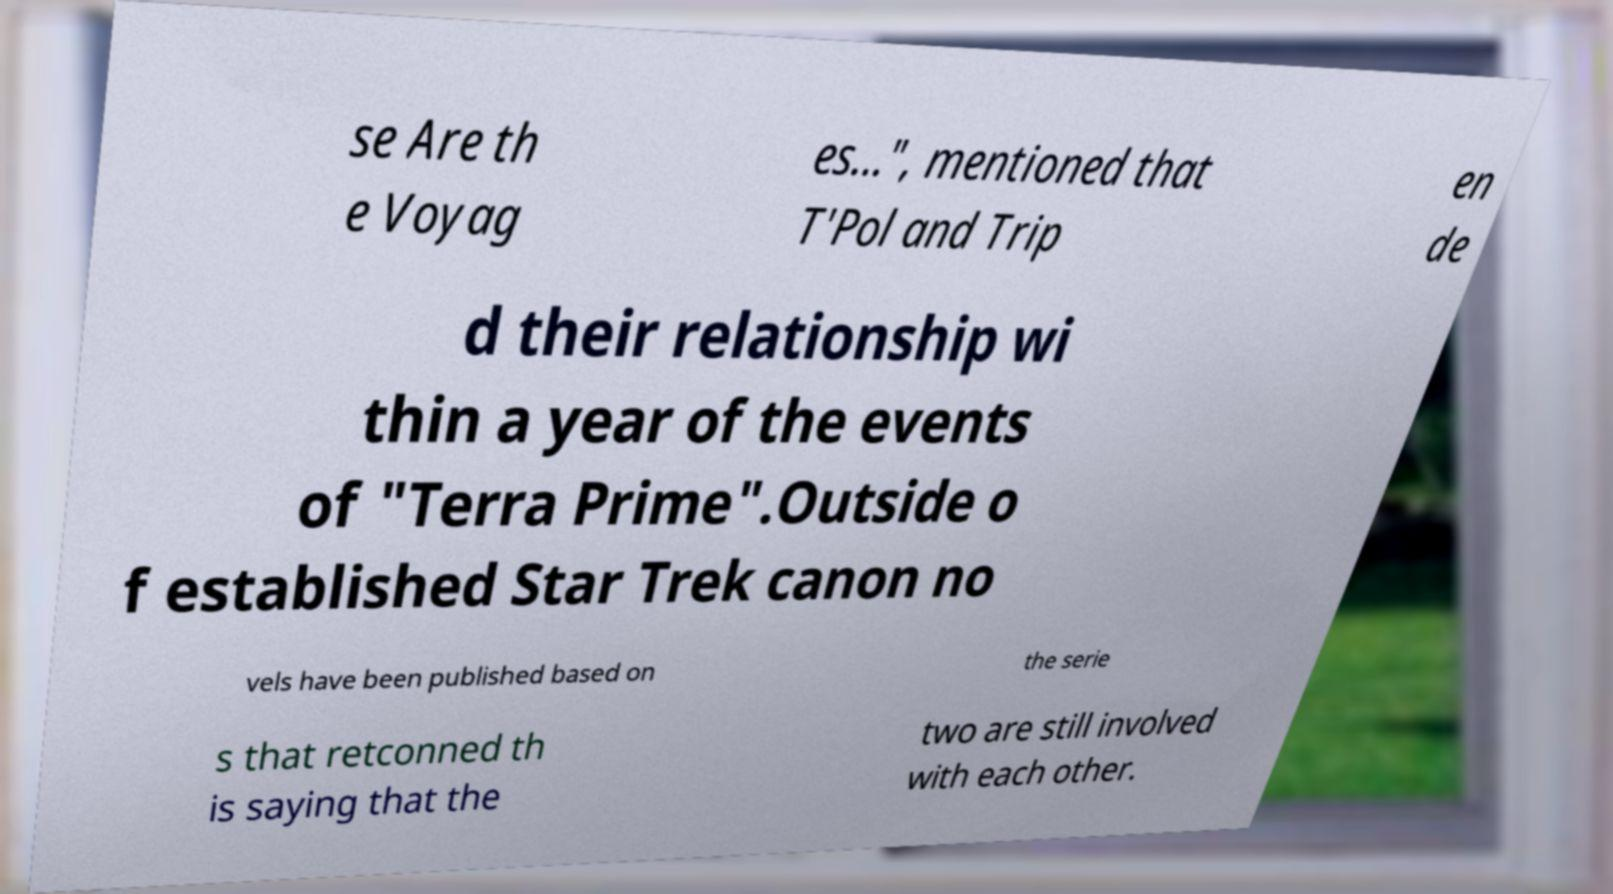Please identify and transcribe the text found in this image. se Are th e Voyag es...", mentioned that T'Pol and Trip en de d their relationship wi thin a year of the events of "Terra Prime".Outside o f established Star Trek canon no vels have been published based on the serie s that retconned th is saying that the two are still involved with each other. 